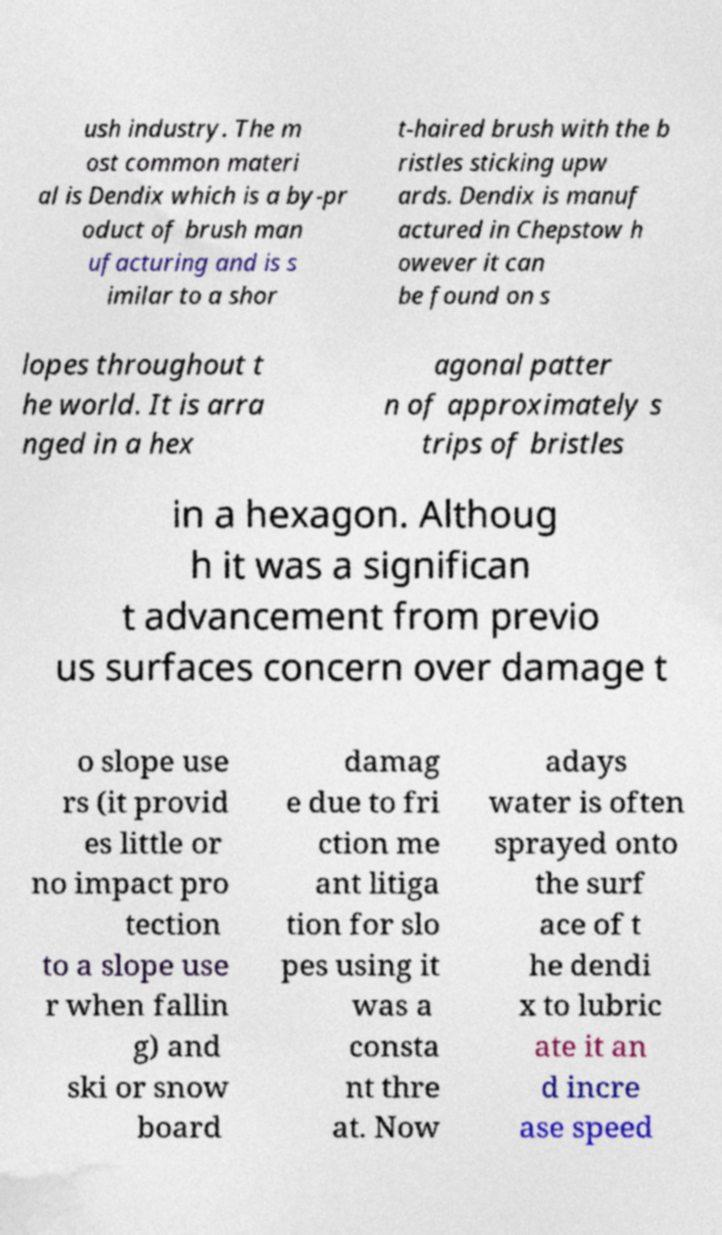Please identify and transcribe the text found in this image. ush industry. The m ost common materi al is Dendix which is a by-pr oduct of brush man ufacturing and is s imilar to a shor t-haired brush with the b ristles sticking upw ards. Dendix is manuf actured in Chepstow h owever it can be found on s lopes throughout t he world. It is arra nged in a hex agonal patter n of approximately s trips of bristles in a hexagon. Althoug h it was a significan t advancement from previo us surfaces concern over damage t o slope use rs (it provid es little or no impact pro tection to a slope use r when fallin g) and ski or snow board damag e due to fri ction me ant litiga tion for slo pes using it was a consta nt thre at. Now adays water is often sprayed onto the surf ace of t he dendi x to lubric ate it an d incre ase speed 